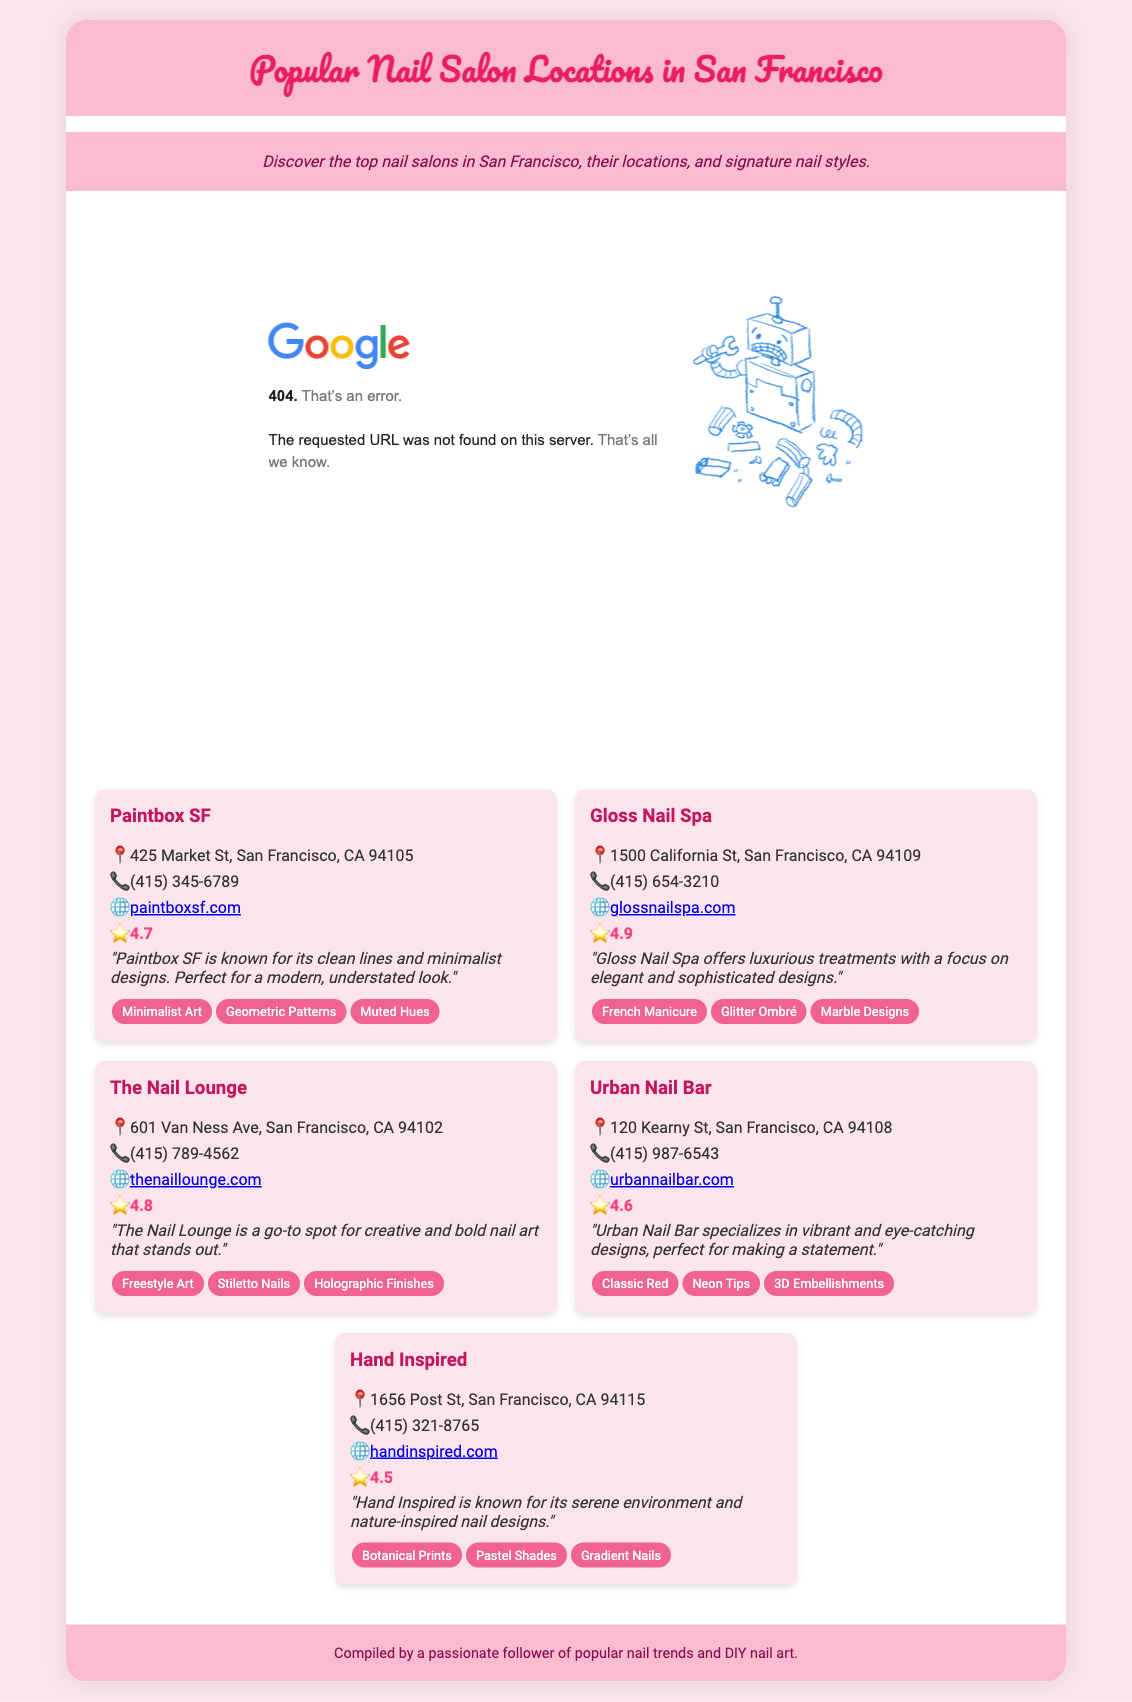What is the address of Paintbox SF? The address of Paintbox SF is listed in the document as its location.
Answer: 425 Market St, San Francisco, CA 94105 What is the average rating of the salons listed? The ratings are provided for each salon, so the average can be calculated by finding the mean of all ratings: (4.7 + 4.9 + 4.8 + 4.6 + 4.5) / 5.
Answer: 4.7 Which salon has the highest rating? The ratings for the salons are specified in the document, allowing us to identify the highest one.
Answer: Gloss Nail Spa What signature style is associated with The Nail Lounge? The document lists signature styles for each salon, including The Nail Lounge.
Answer: Freestyle Art How many nail salons are featured in the document? The number of salons can be counted from the information provided in the document.
Answer: 5 What design styles are associated with Urban Nail Bar? The document includes a section on signature styles for the Urban Nail Bar, listing multiple styles.
Answer: Classic Red, Neon Tips, 3D Embellishments What is the phone number for Hand Inspired? The phone number for Hand Inspired is included in the salon’s section to provide contact information.
Answer: (415) 321-8765 Which salon specializes in minimalistic designs? The focus of each salon is described, revealing which one specializes in minimalistic aesthetics.
Answer: Paintbox SF 